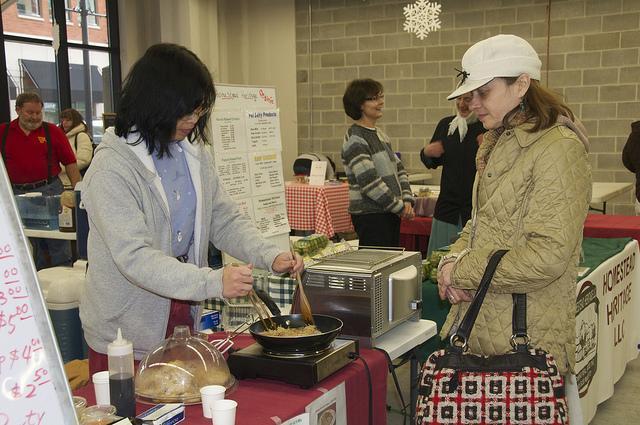How many people are wearing red shirts?
Give a very brief answer. 1. How many people can be seen?
Give a very brief answer. 5. 